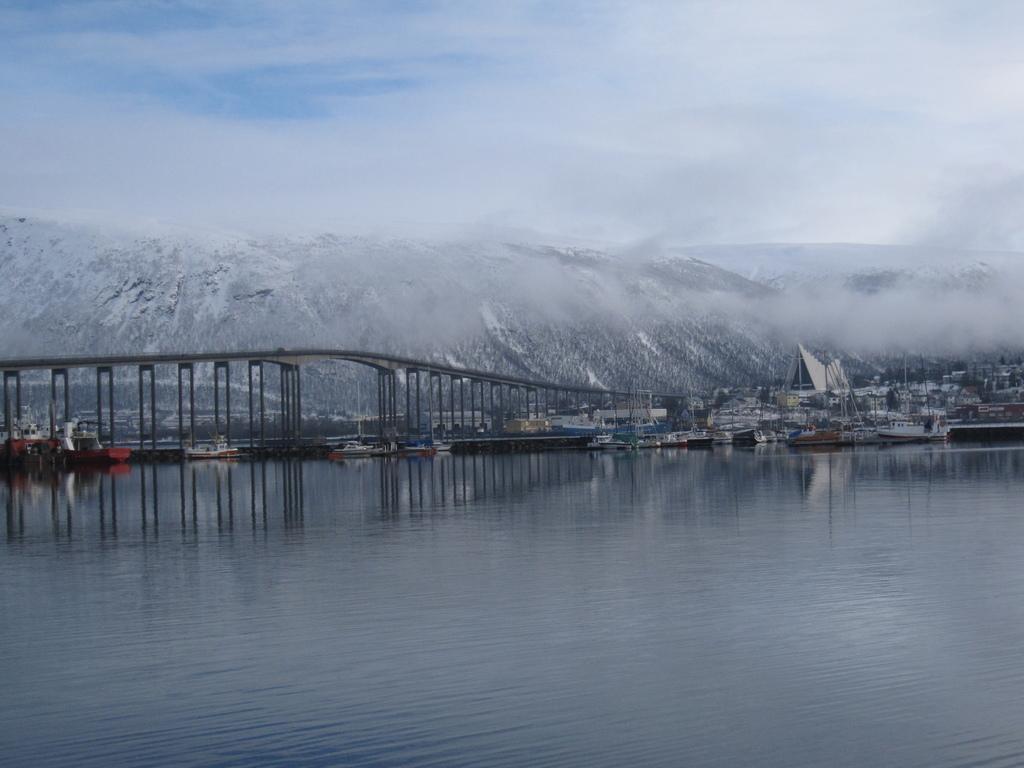Could you give a brief overview of what you see in this image? In this image there is the water. There is a bridge across the water. There are boats on the water. In the background there are mountains. At the top there is the sky. There is the fog in the image. 